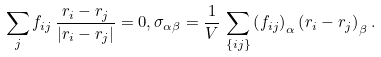Convert formula to latex. <formula><loc_0><loc_0><loc_500><loc_500>\sum _ { j } f _ { i j } \, \frac { { r } _ { i } - { r } _ { j } } { | { r } _ { i } - { r } _ { j } | } = { 0 } , \sigma _ { \alpha \beta } = \frac { 1 } { V } \, \sum _ { \{ i j \} } \left ( { f } _ { i j } \right ) _ { \alpha } \left ( { r } _ { i } - { r } _ { j } \right ) _ { \beta } .</formula> 